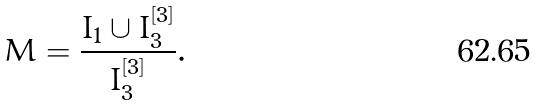Convert formula to latex. <formula><loc_0><loc_0><loc_500><loc_500>M = \frac { I _ { 1 } \cup I _ { 3 } ^ { [ 3 ] } } { I _ { 3 } ^ { [ 3 ] } } .</formula> 